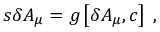Convert formula to latex. <formula><loc_0><loc_0><loc_500><loc_500>s \delta A _ { \mu } = g \left [ \delta A _ { \mu } , c \right ] \, ,</formula> 